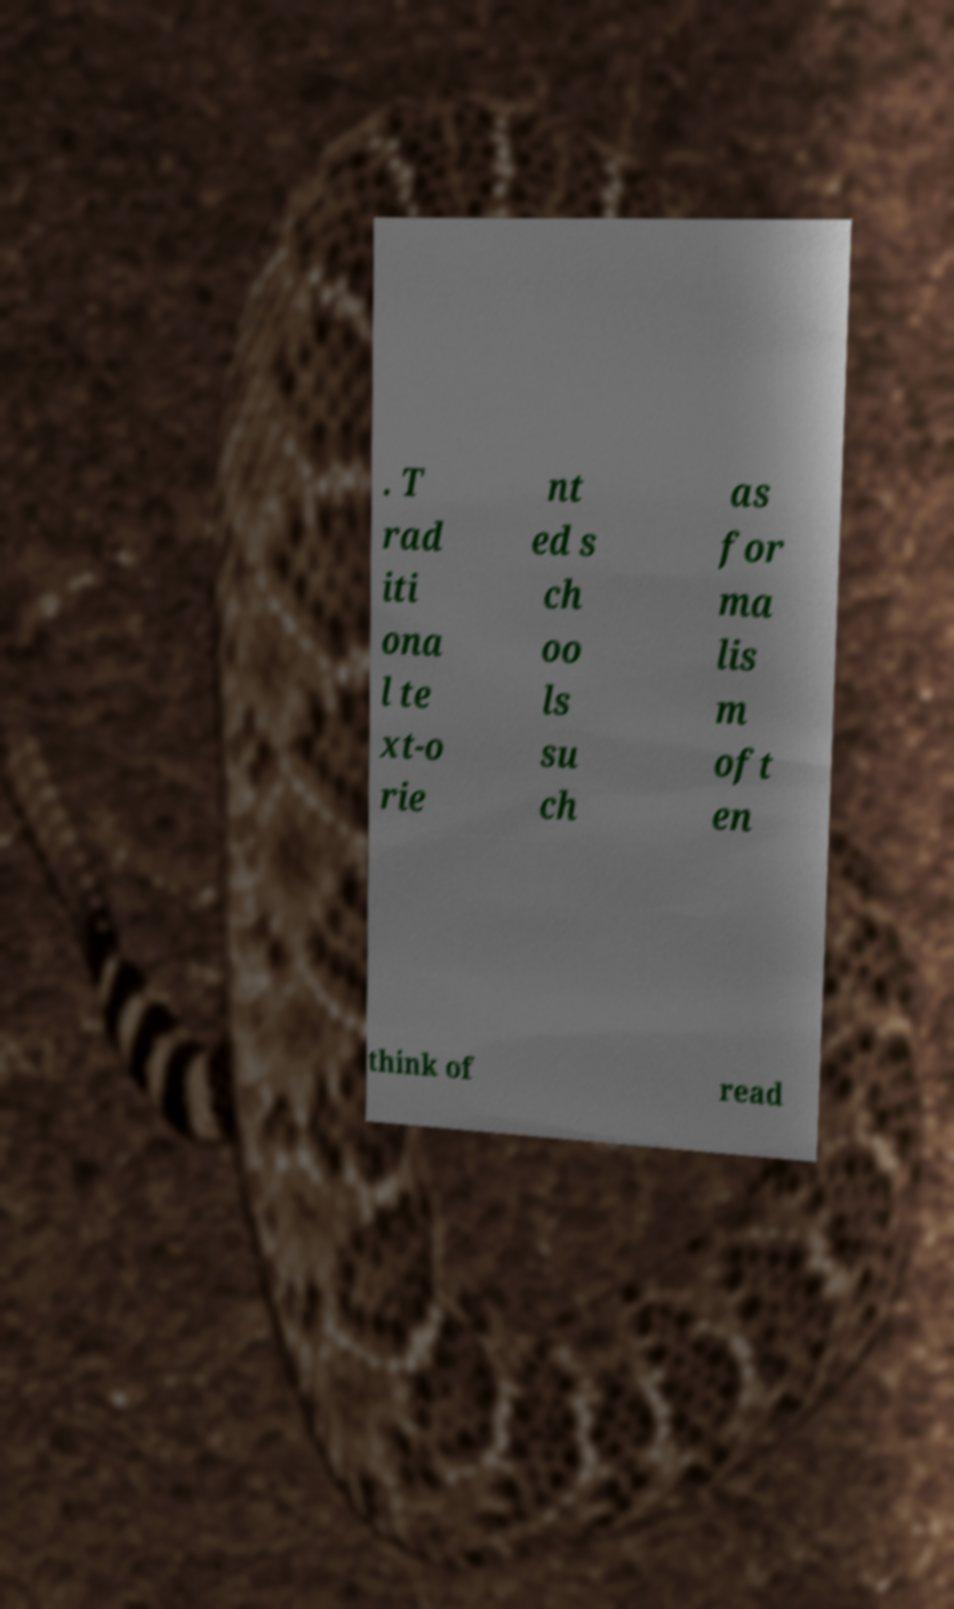There's text embedded in this image that I need extracted. Can you transcribe it verbatim? . T rad iti ona l te xt-o rie nt ed s ch oo ls su ch as for ma lis m oft en think of read 